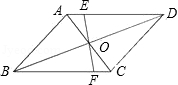What can you infer about the relationships between the angles at point O? Point O, being the intersection of the diagonals of parallelogram ABCD, implies that the angles at O are congruent. This is because diagonals of a parallelogram bisect each other, creating congruent triangles AOB and COD and BOC and AOD, thus making all angles at O equal. 